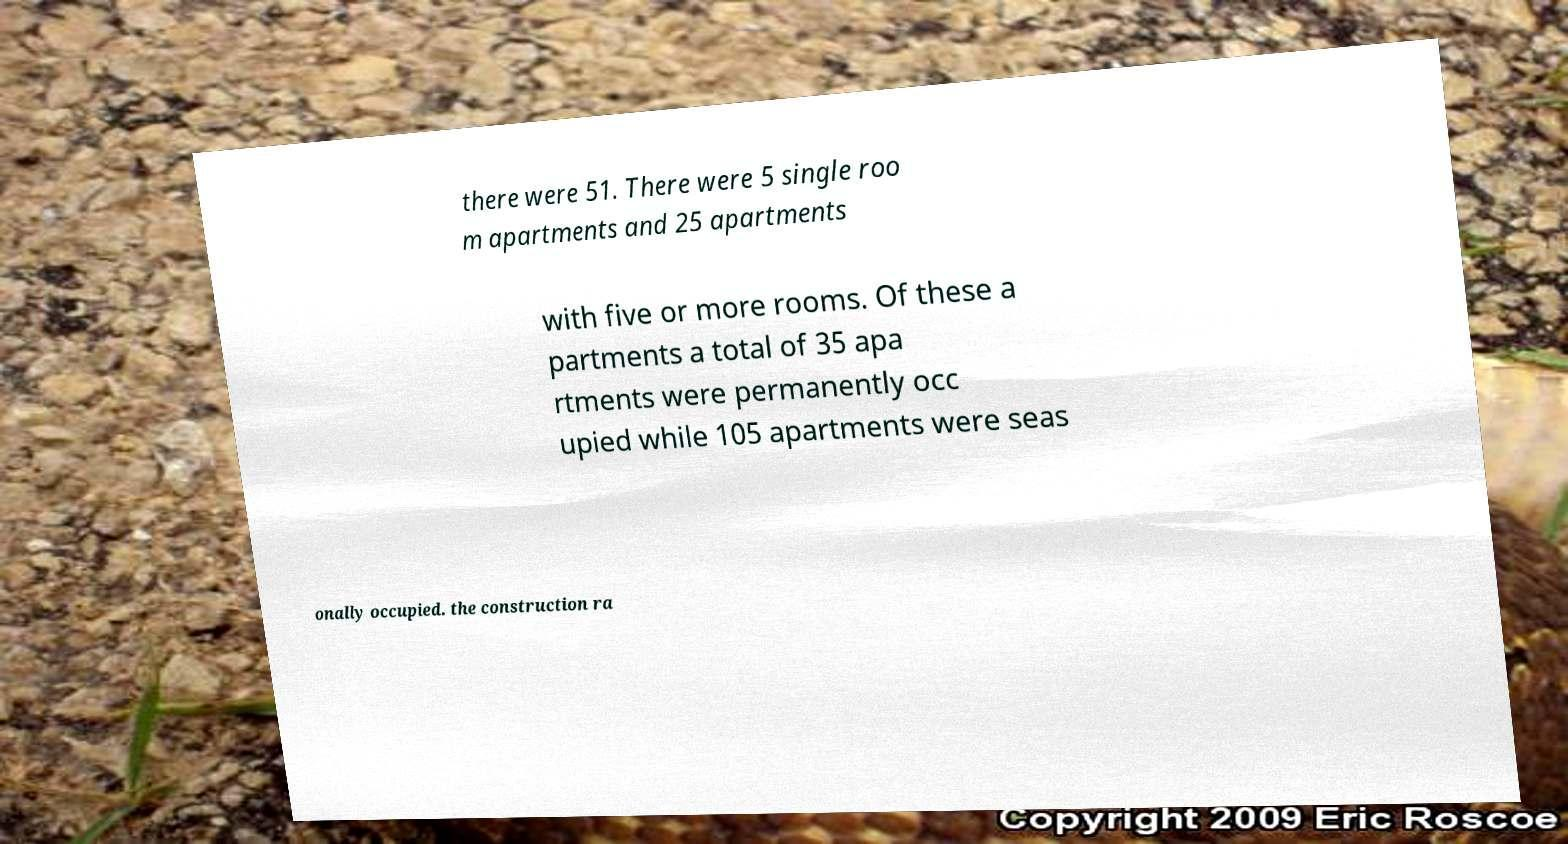Could you extract and type out the text from this image? there were 51. There were 5 single roo m apartments and 25 apartments with five or more rooms. Of these a partments a total of 35 apa rtments were permanently occ upied while 105 apartments were seas onally occupied. the construction ra 